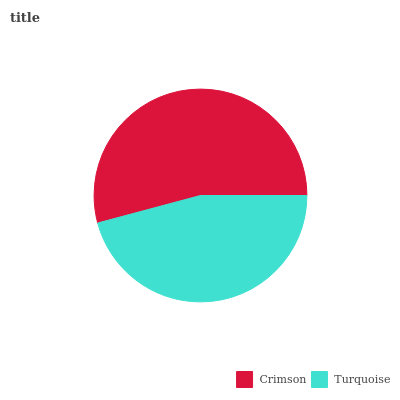Is Turquoise the minimum?
Answer yes or no. Yes. Is Crimson the maximum?
Answer yes or no. Yes. Is Turquoise the maximum?
Answer yes or no. No. Is Crimson greater than Turquoise?
Answer yes or no. Yes. Is Turquoise less than Crimson?
Answer yes or no. Yes. Is Turquoise greater than Crimson?
Answer yes or no. No. Is Crimson less than Turquoise?
Answer yes or no. No. Is Crimson the high median?
Answer yes or no. Yes. Is Turquoise the low median?
Answer yes or no. Yes. Is Turquoise the high median?
Answer yes or no. No. Is Crimson the low median?
Answer yes or no. No. 